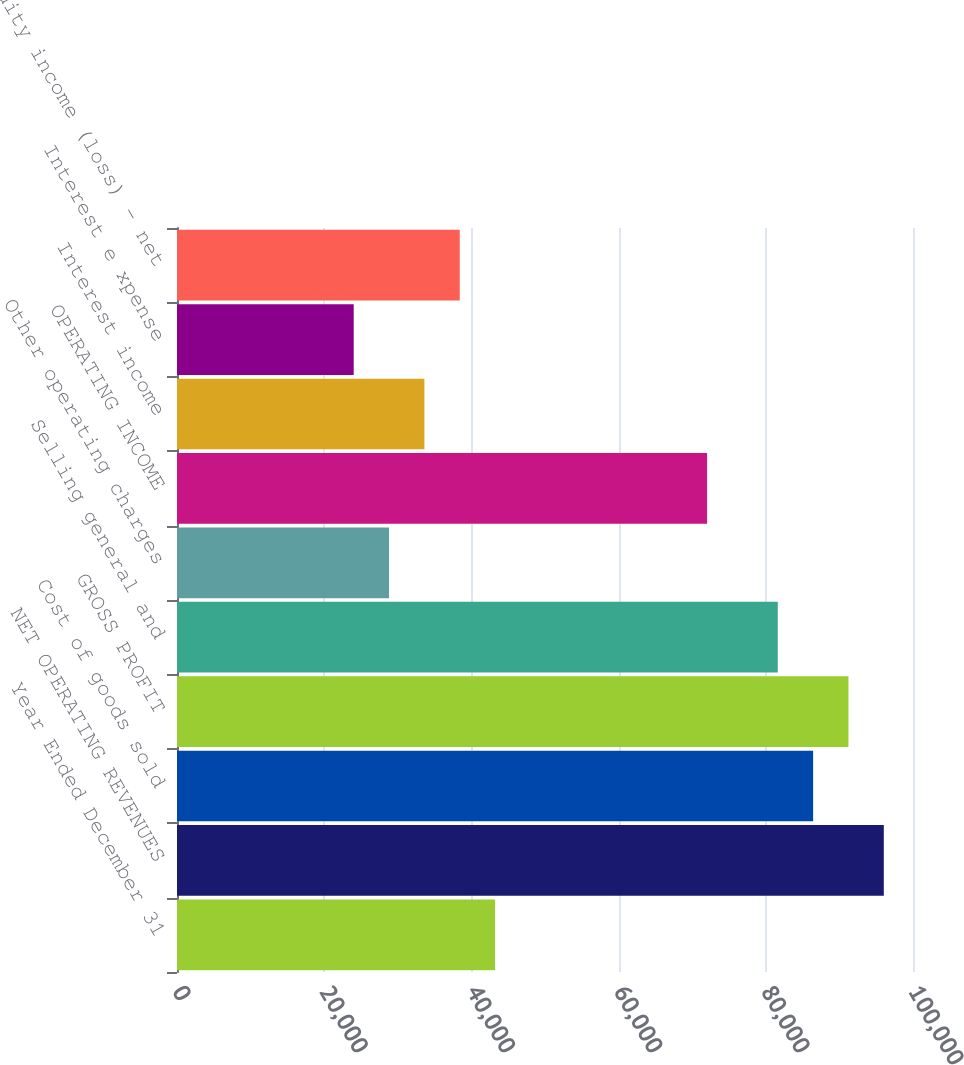<chart> <loc_0><loc_0><loc_500><loc_500><bar_chart><fcel>Year Ended December 31<fcel>NET OPERATING REVENUES<fcel>Cost of goods sold<fcel>GROSS PROFIT<fcel>Selling general and<fcel>Other operating charges<fcel>OPERATING INCOME<fcel>Interest income<fcel>Interest e xpense<fcel>Equity income (loss) - net<nl><fcel>43215.5<fcel>96032<fcel>86429<fcel>91230.5<fcel>81627.5<fcel>28811<fcel>72024.5<fcel>33612.5<fcel>24009.5<fcel>38414<nl></chart> 